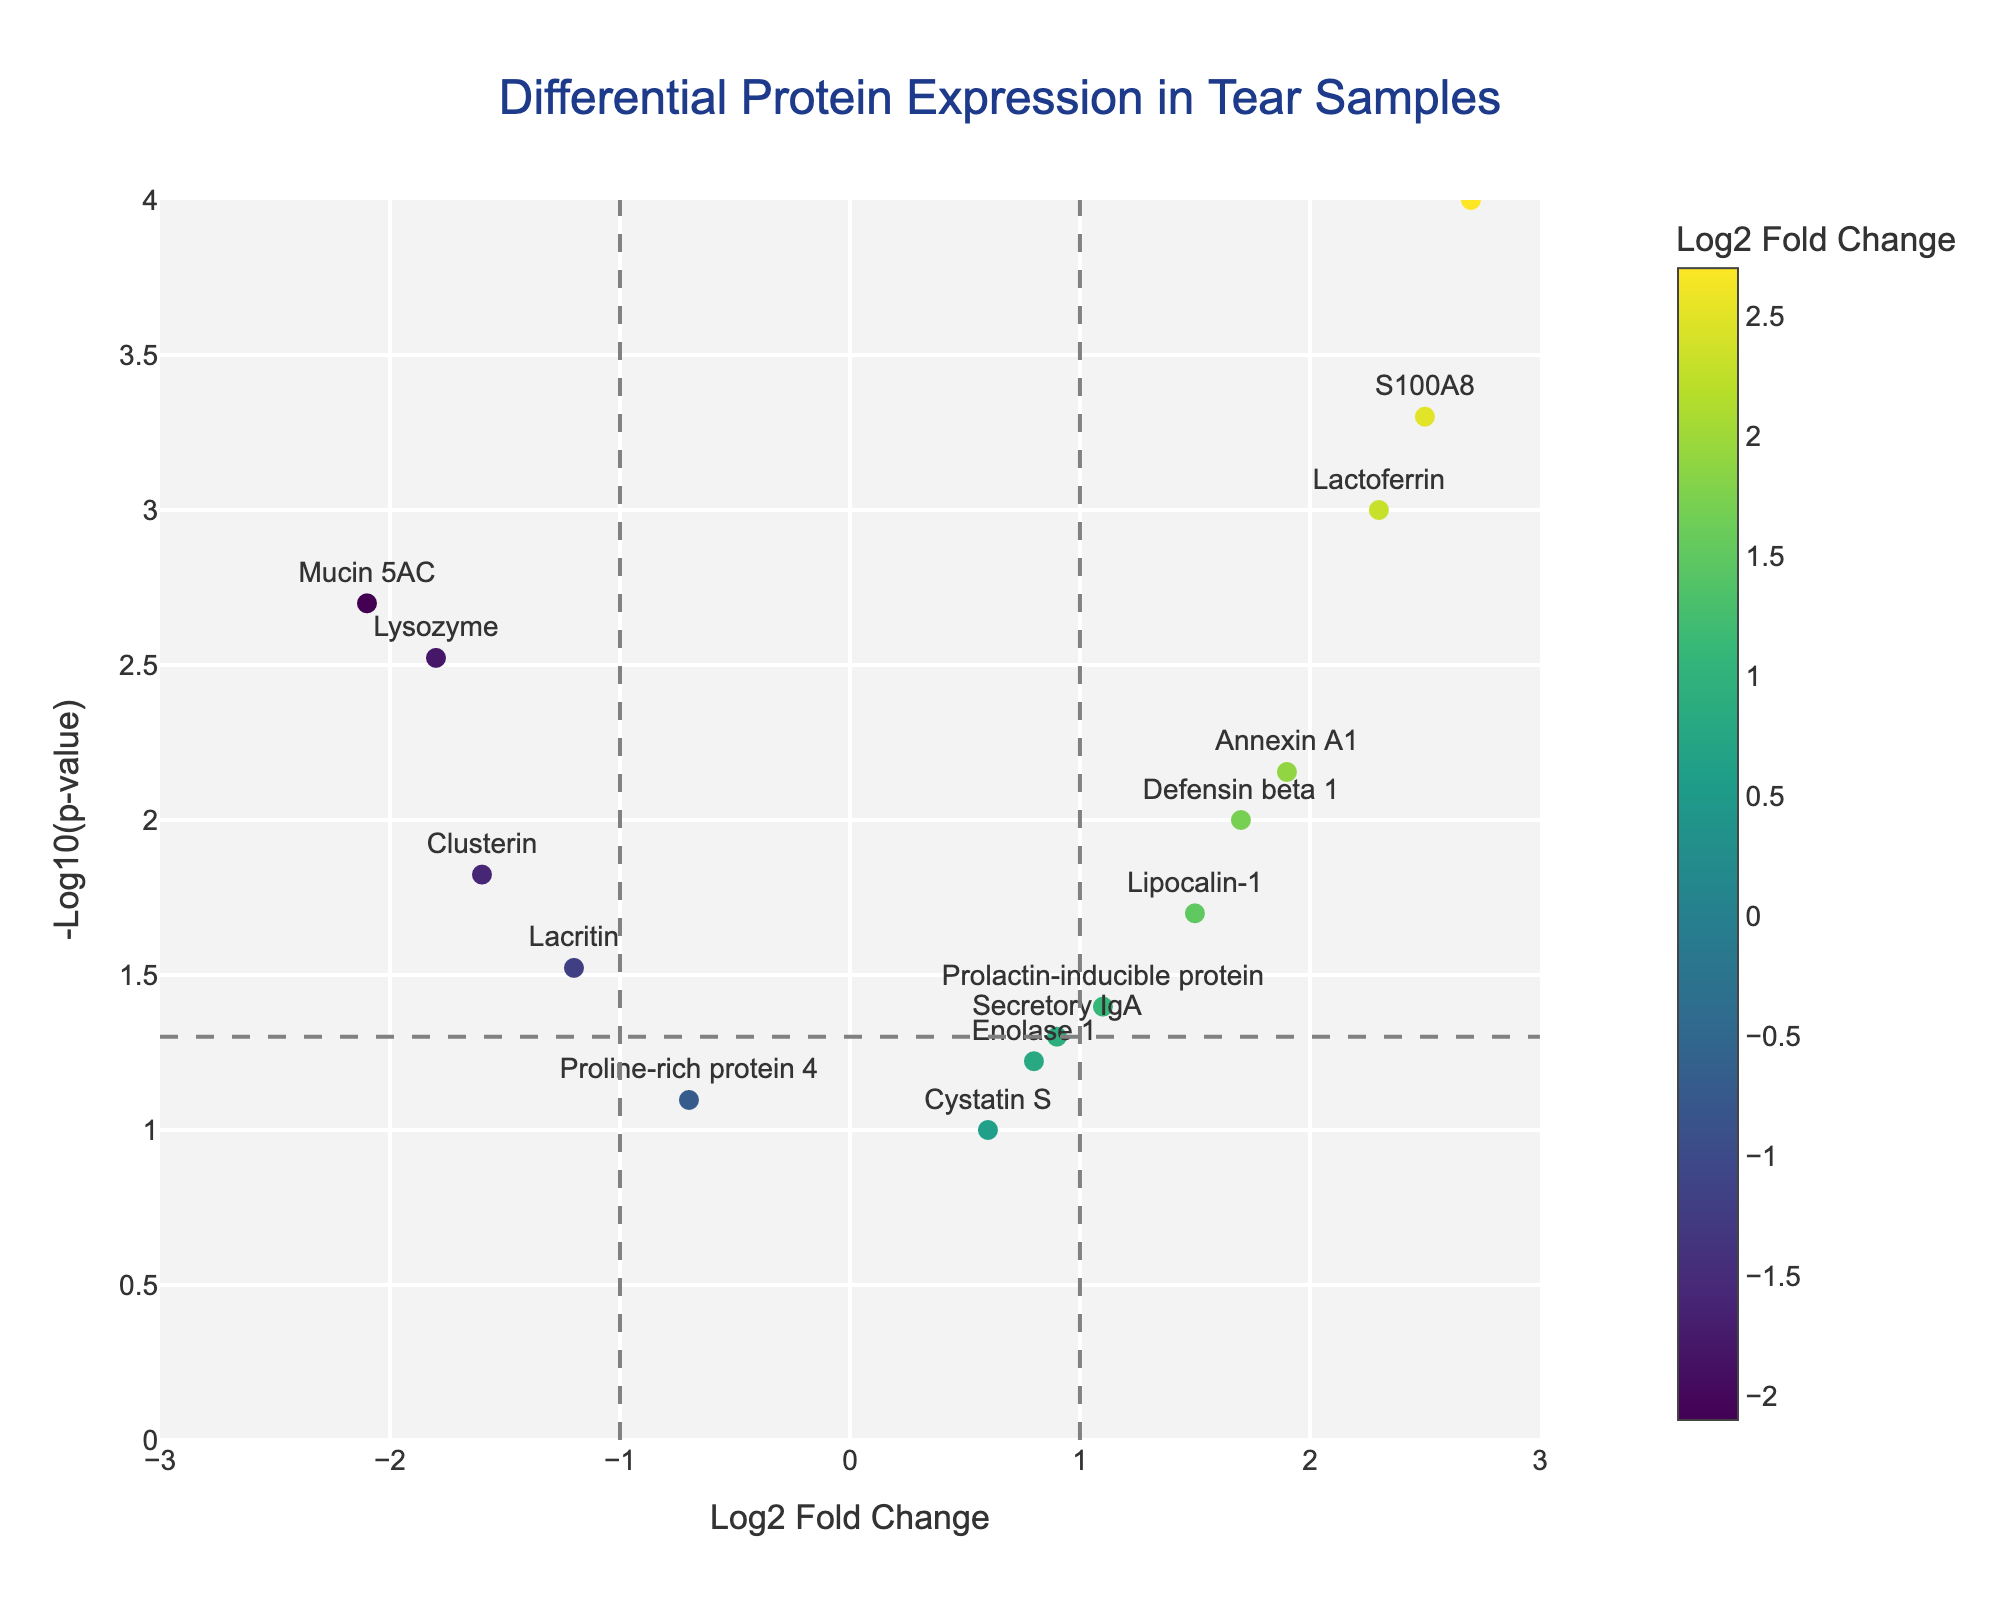What is the title of the figure? The title of the figure is displayed at the top center. It reads "Differential Protein Expression in Tear Samples".
Answer: Differential Protein Expression in Tear Samples What do the x and y axes represent? The x-axis represents the "Log2 Fold Change", and the y-axis represents the "-Log10(p-value)". These labels are visible along the corresponding axes.
Answer: Log2 Fold Change and -Log10(p-value) Which protein has the highest fold change? To find the highest fold change, identify the data point with the highest value on the x-axis. Matrix metalloproteinase 9 (MMP-9) stands out at approximately 2.7
Answer: Matrix metalloproteinase 9 How many proteins have a p-value less than 0.05? Proteins with a p-value less than 0.05 are above the horizontal line at y = -log10(0.05) = 1.3. Count these data points: Lactoferrin, Lysozyme, Mucin 5AC, Defensin beta 1, S100A8, Annexin A1, and Clusterin.
Answer: 7 Which protein has the most significant p-value among those listed? The most significant p-value corresponds to the highest y-axis value since -log10(p-value) is plotted on the y-axis. Matrix metalloproteinase 9 has the highest value at approximately 4.
Answer: Matrix metalloproteinase 9 Compare the fold changes and p-values of Lactoferrin and Lysozyme. Which has a higher fold change and which is more significant? Compare the x and y coordinates of the two proteins. Lactoferrin has a fold change of 2.3 and Lysozyme -1.8, so Lactoferrin has a higher fold change. However, Lactoferrin's p-value is 0.001 vs. Lysozyme's 0.003, so Lactoferrin is also more significant.
Answer: Lactoferrin How many proteins show downregulation with a p-value less than 0.05? Downregulated proteins have a negative fold change (left of 0) and significance above 1.3 on the y-axis. These are Lysozyme, Mucin 5AC, and Clusterin.
Answer: 3 Which proteins fall within the non-significant p-value range (p > 0.05)? Non-significant proteins fall below the horizontal line at y = 1.3 (p > 0.05). Look for points below this line: Proline-rich protein 4, Cystatin S, and Enolase 1.
Answer: 3 What can you conclude about the differential expression of Defensin beta 1 compared to Annexin A1? Both have positive fold changes and significant p-values (above the threshold line). Defensin beta 1 has a fold change of 1.7 and Annexin A1 at 1.9, with p-values 0.01 and 0.007, respectively. Both are similar in regulation and significance.
Answer: Similar What threshold is used to indicate significance on the plot? Where is the threshold line located? The significance threshold line is at y = -log10(0.05) = 1.3, shown as a horizontal dashed line on the plot.
Answer: 1.3 